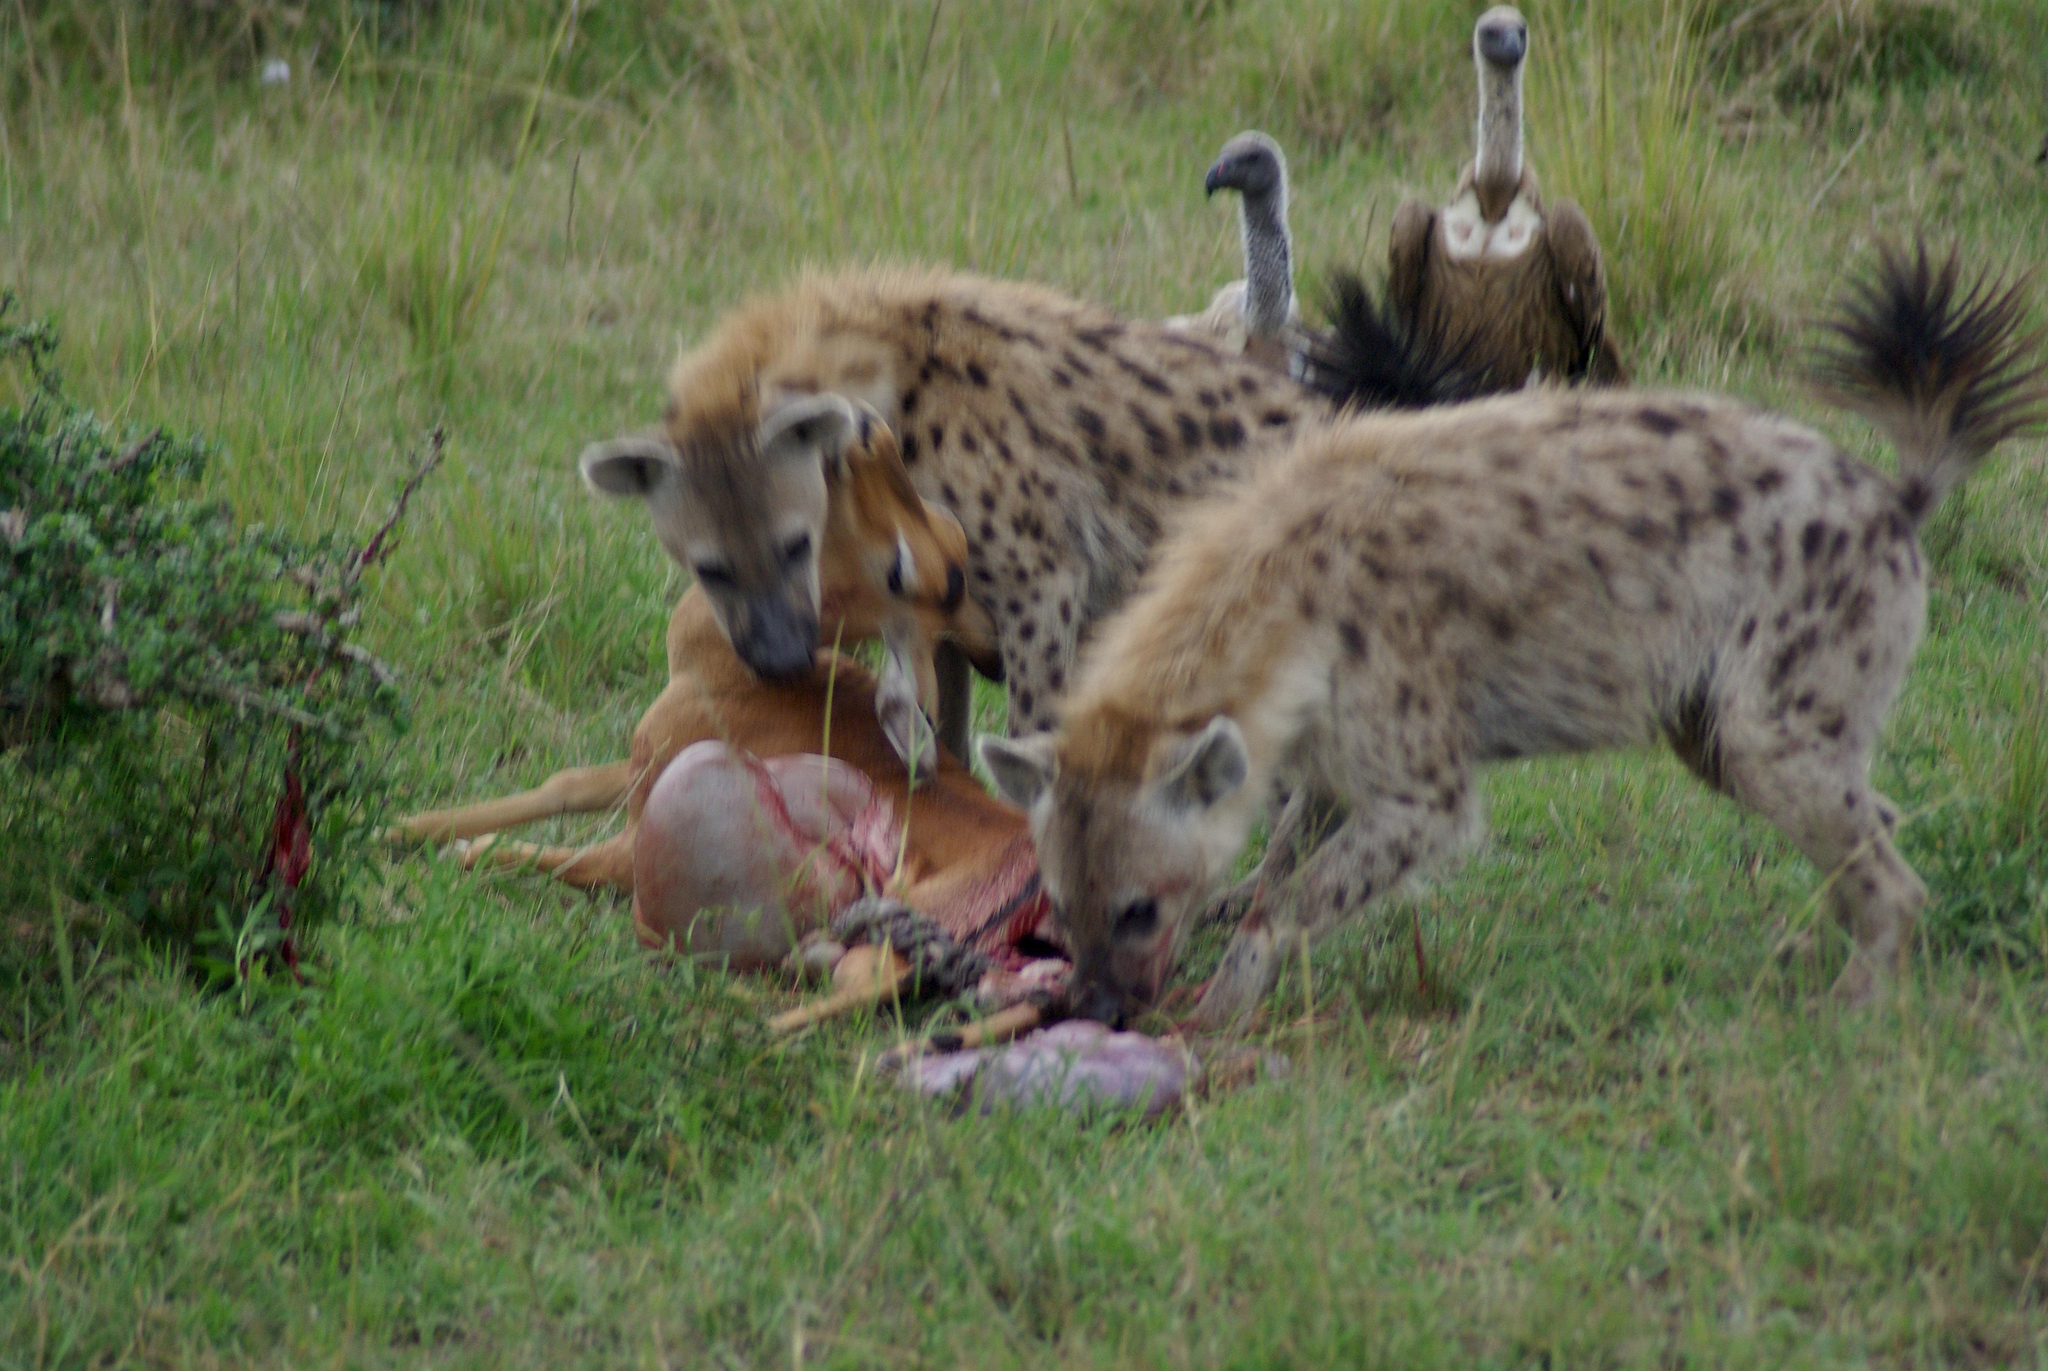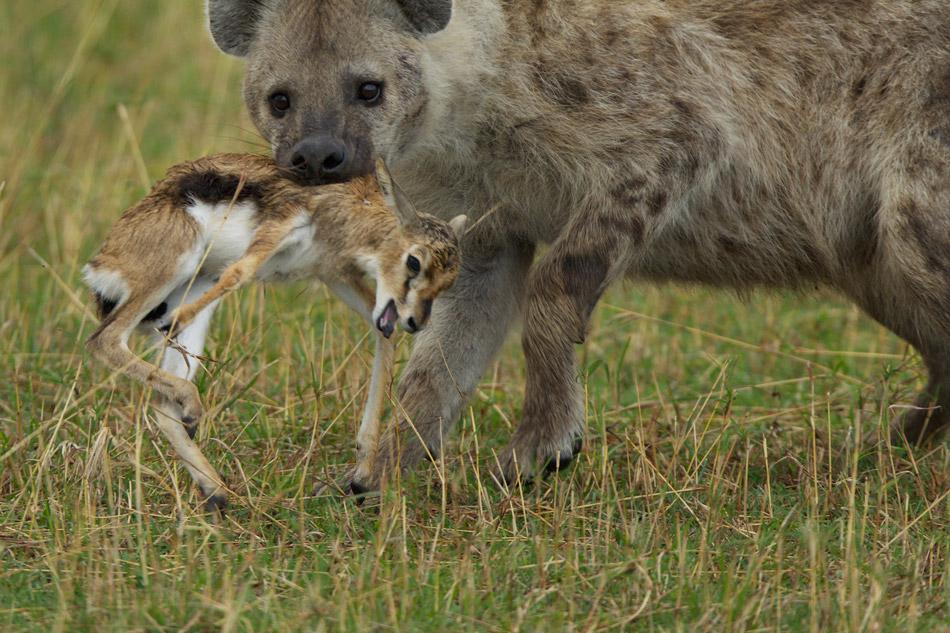The first image is the image on the left, the second image is the image on the right. Given the left and right images, does the statement "Right image shows a hyena with nothing in its mouth." hold true? Answer yes or no. No. The first image is the image on the left, the second image is the image on the right. Examine the images to the left and right. Is the description "1 hyena with no prey in its mouth is walking toward the left." accurate? Answer yes or no. No. 